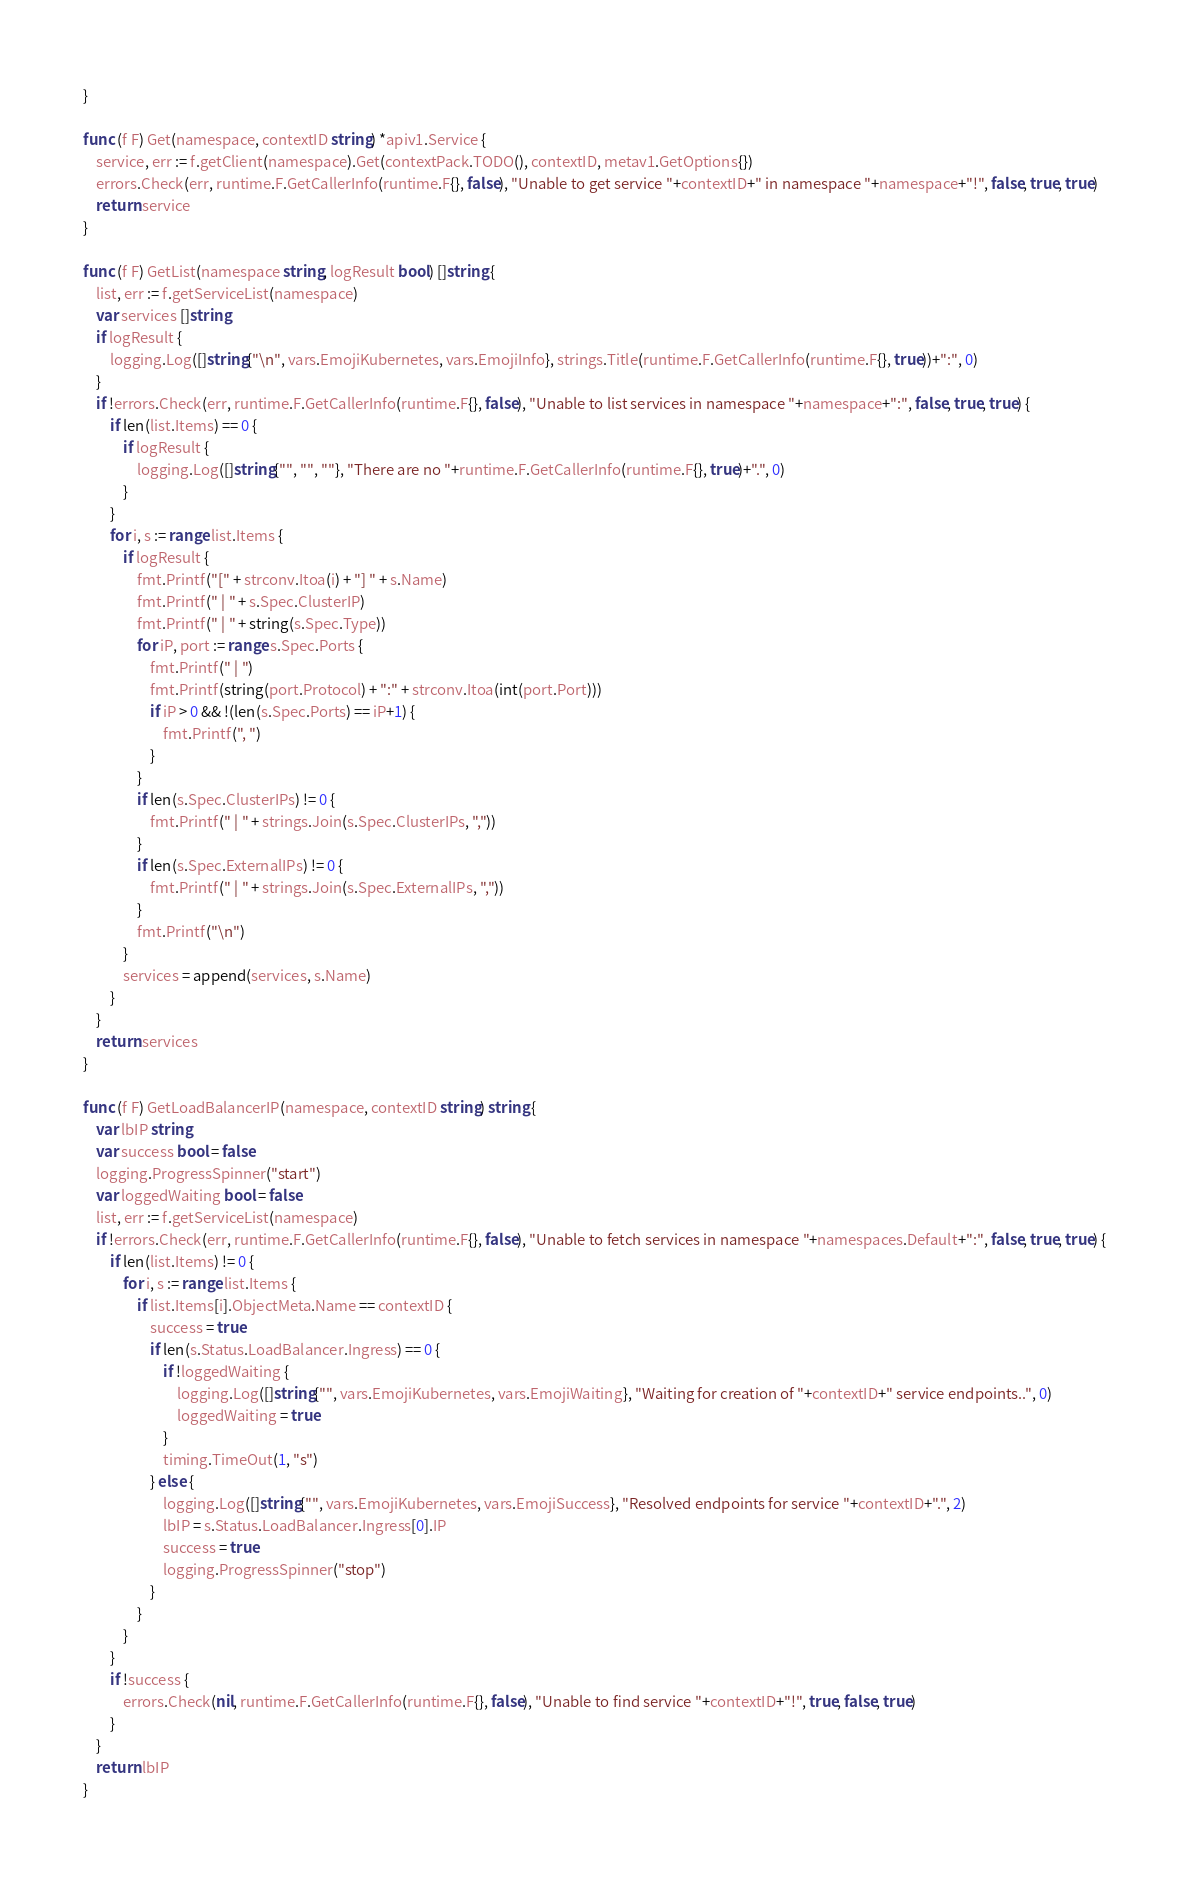<code> <loc_0><loc_0><loc_500><loc_500><_Go_>}

func (f F) Get(namespace, contextID string) *apiv1.Service {
	service, err := f.getClient(namespace).Get(contextPack.TODO(), contextID, metav1.GetOptions{})
	errors.Check(err, runtime.F.GetCallerInfo(runtime.F{}, false), "Unable to get service "+contextID+" in namespace "+namespace+"!", false, true, true)
	return service
}

func (f F) GetList(namespace string, logResult bool) []string {
	list, err := f.getServiceList(namespace)
	var services []string
	if logResult {
		logging.Log([]string{"\n", vars.EmojiKubernetes, vars.EmojiInfo}, strings.Title(runtime.F.GetCallerInfo(runtime.F{}, true))+":", 0)
	}
	if !errors.Check(err, runtime.F.GetCallerInfo(runtime.F{}, false), "Unable to list services in namespace "+namespace+":", false, true, true) {
		if len(list.Items) == 0 {
			if logResult {
				logging.Log([]string{"", "", ""}, "There are no "+runtime.F.GetCallerInfo(runtime.F{}, true)+".", 0)
			}
		}
		for i, s := range list.Items {
			if logResult {
				fmt.Printf("[" + strconv.Itoa(i) + "] " + s.Name)
				fmt.Printf(" | " + s.Spec.ClusterIP)
				fmt.Printf(" | " + string(s.Spec.Type))
				for iP, port := range s.Spec.Ports {
					fmt.Printf(" | ")
					fmt.Printf(string(port.Protocol) + ":" + strconv.Itoa(int(port.Port)))
					if iP > 0 && !(len(s.Spec.Ports) == iP+1) {
						fmt.Printf(", ")
					}
				}
				if len(s.Spec.ClusterIPs) != 0 {
					fmt.Printf(" | " + strings.Join(s.Spec.ClusterIPs, ","))
				}
				if len(s.Spec.ExternalIPs) != 0 {
					fmt.Printf(" | " + strings.Join(s.Spec.ExternalIPs, ","))
				}
				fmt.Printf("\n")
			}
			services = append(services, s.Name)
		}
	}
	return services
}

func (f F) GetLoadBalancerIP(namespace, contextID string) string {
	var lbIP string
	var success bool = false
	logging.ProgressSpinner("start")
	var loggedWaiting bool = false
	list, err := f.getServiceList(namespace)
	if !errors.Check(err, runtime.F.GetCallerInfo(runtime.F{}, false), "Unable to fetch services in namespace "+namespaces.Default+":", false, true, true) {
		if len(list.Items) != 0 {
			for i, s := range list.Items {
				if list.Items[i].ObjectMeta.Name == contextID {
					success = true
					if len(s.Status.LoadBalancer.Ingress) == 0 {
						if !loggedWaiting {
							logging.Log([]string{"", vars.EmojiKubernetes, vars.EmojiWaiting}, "Waiting for creation of "+contextID+" service endpoints..", 0)
							loggedWaiting = true
						}
						timing.TimeOut(1, "s")
					} else {
						logging.Log([]string{"", vars.EmojiKubernetes, vars.EmojiSuccess}, "Resolved endpoints for service "+contextID+".", 2)
						lbIP = s.Status.LoadBalancer.Ingress[0].IP
						success = true
						logging.ProgressSpinner("stop")
					}
				}
			}
		}
		if !success {
			errors.Check(nil, runtime.F.GetCallerInfo(runtime.F{}, false), "Unable to find service "+contextID+"!", true, false, true)
		}
	}
	return lbIP
}
</code> 